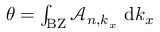Convert formula to latex. <formula><loc_0><loc_0><loc_500><loc_500>\begin{array} { r } { \theta = \int _ { B Z } \mathcal { A } _ { n , k _ { x } } \ d k _ { x } } \end{array}</formula> 